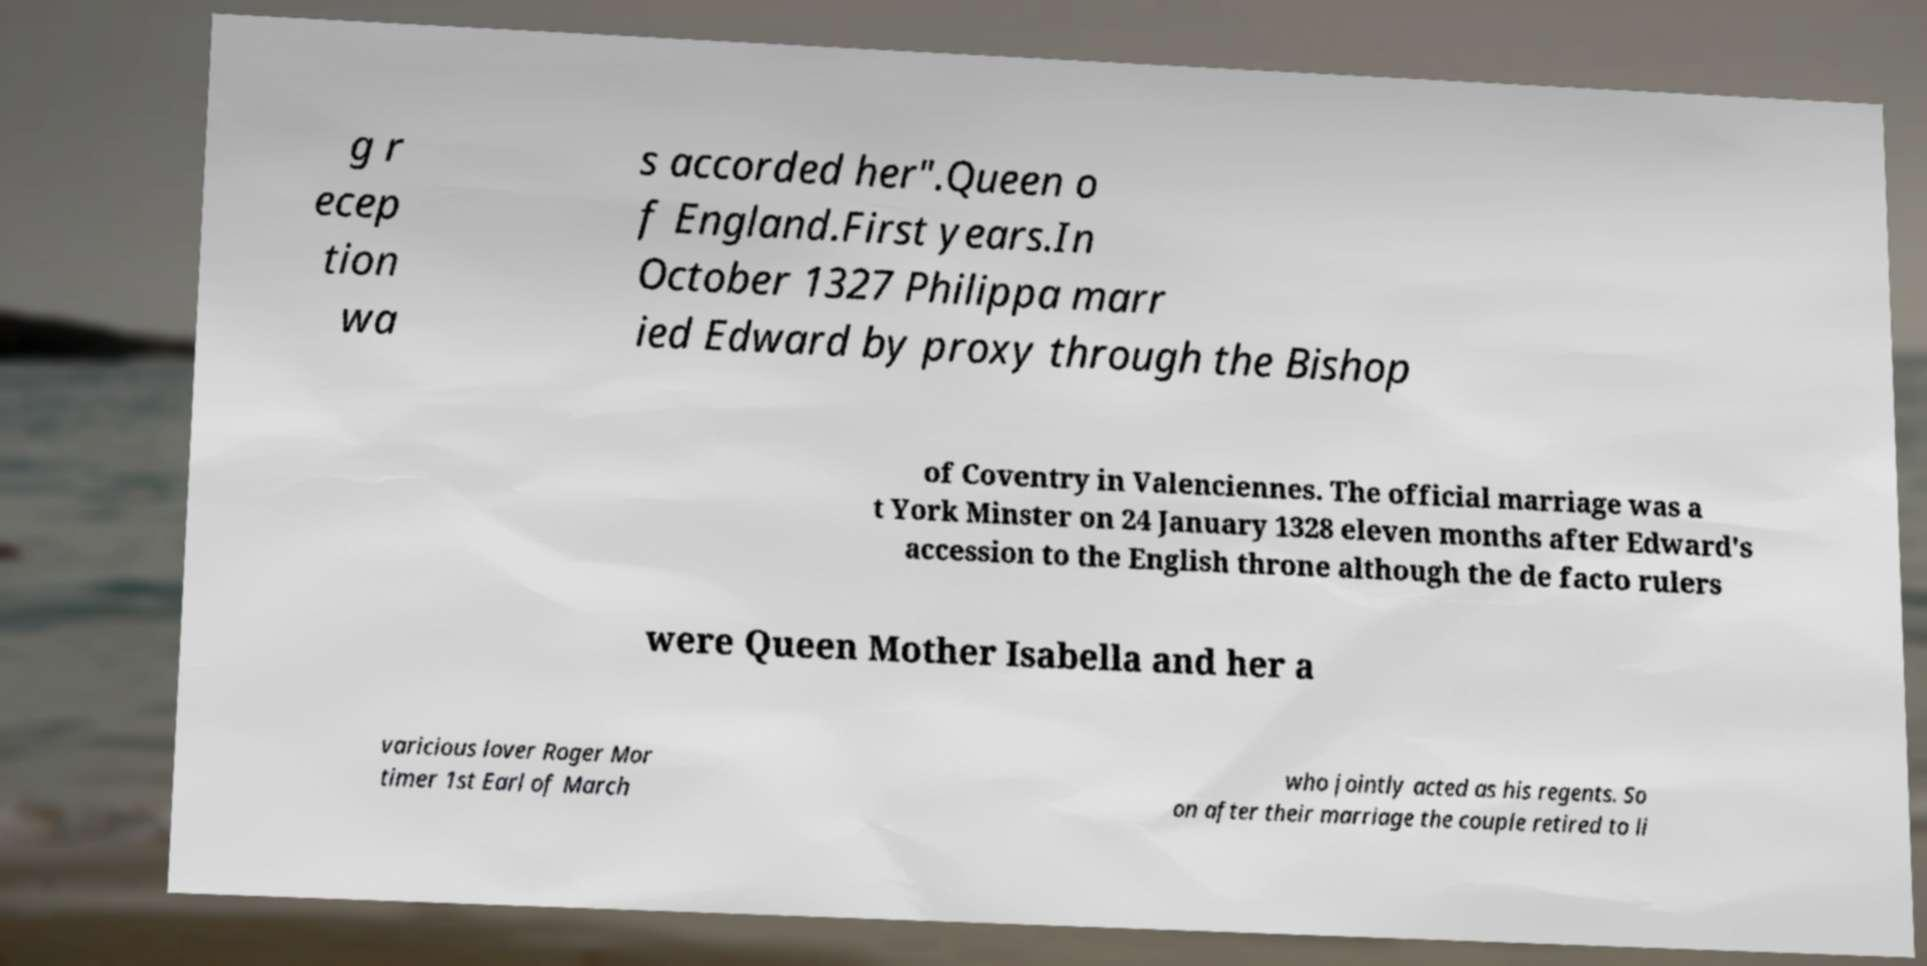Can you accurately transcribe the text from the provided image for me? g r ecep tion wa s accorded her".Queen o f England.First years.In October 1327 Philippa marr ied Edward by proxy through the Bishop of Coventry in Valenciennes. The official marriage was a t York Minster on 24 January 1328 eleven months after Edward's accession to the English throne although the de facto rulers were Queen Mother Isabella and her a varicious lover Roger Mor timer 1st Earl of March who jointly acted as his regents. So on after their marriage the couple retired to li 